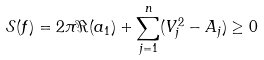<formula> <loc_0><loc_0><loc_500><loc_500>\mathcal { S } ( f ) = 2 \pi \Re ( a _ { 1 } ) + \sum _ { j = 1 } ^ { n } ( V _ { j } ^ { 2 } - A _ { j } ) \geq 0</formula> 